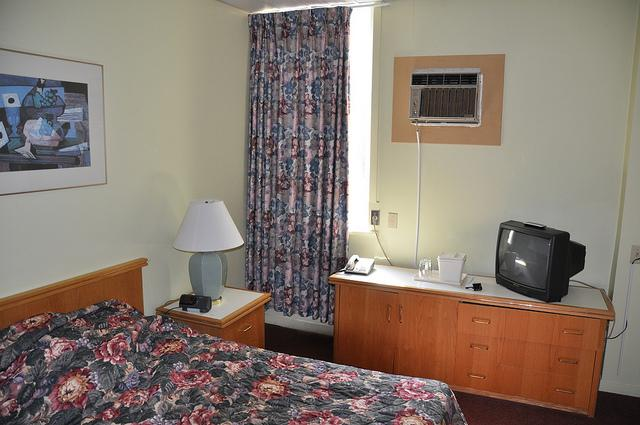What is on the dresser? Please explain your reasoning. television. It is a characteristic shape to hold tubes inside and a screen that displays a picture. it is common for people to put it where they can watch it from bed. 